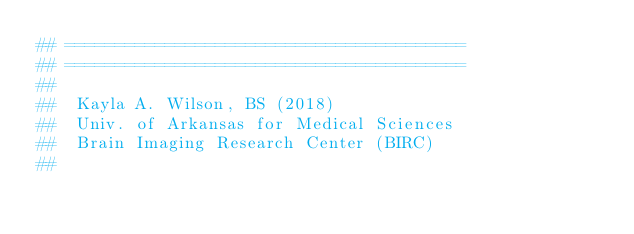Convert code to text. <code><loc_0><loc_0><loc_500><loc_500><_Python_>## ========================================
## ========================================
##
##  Kayla A. Wilson, BS (2018)
##  Univ. of Arkansas for Medical Sciences
##  Brain Imaging Research Center (BIRC)
##</code> 